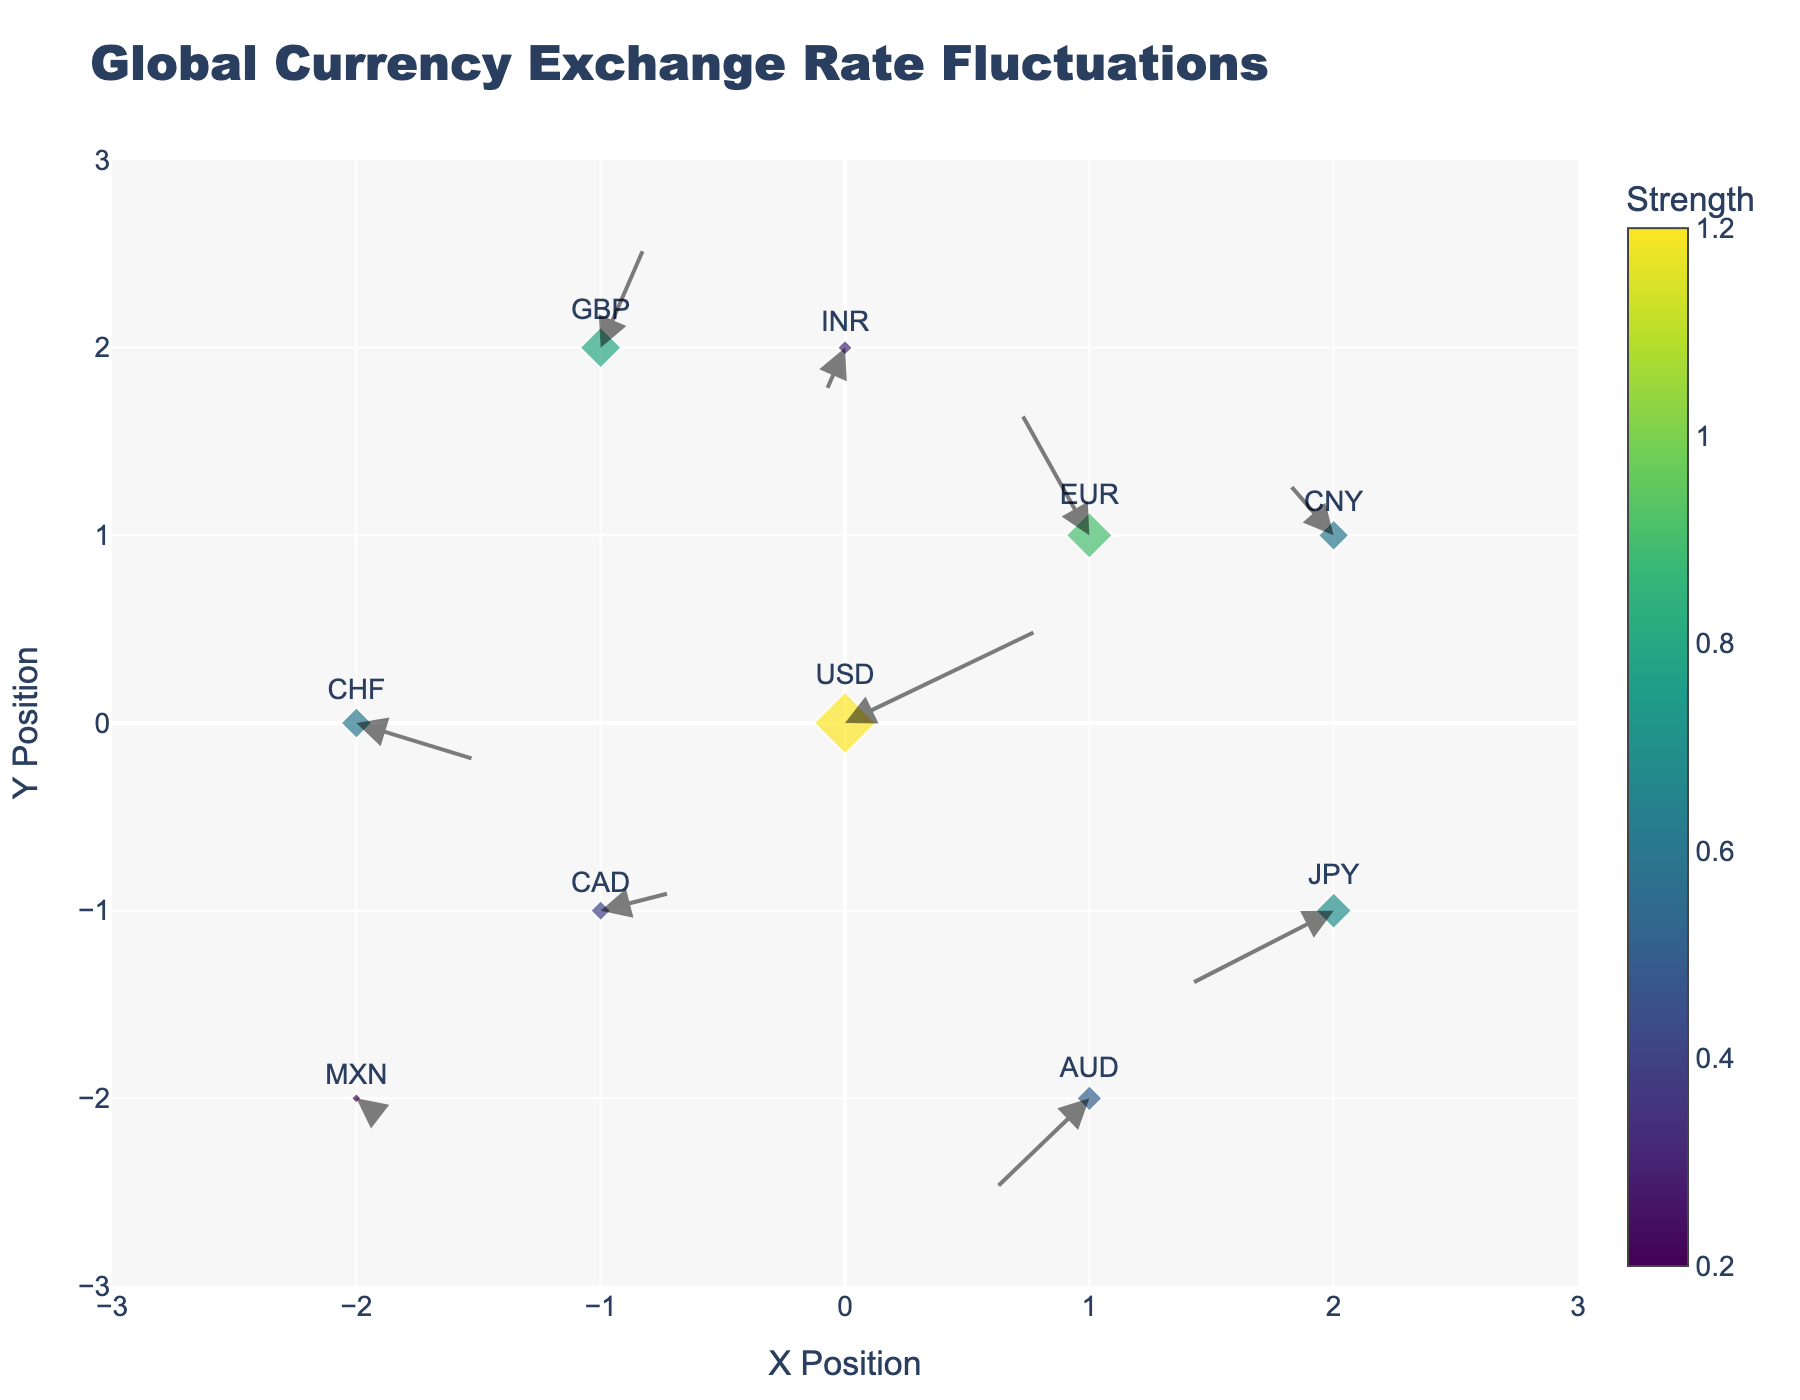What is the title of the figure? The title is located at the top-center of the plot and usually provides the main subject of the visualization. In this case, it reads "Global Currency Exchange Rate Fluctuations."
Answer: Global Currency Exchange Rate Fluctuations How many currencies are represented in the plot? By counting the labeled markers in the plot, one can identify each currency. There are 10 labeled markers indicating 10 different currencies.
Answer: 10 Which currency has the highest strength value? By observing the size of the markers and the color bar, the currency with the largest marker size and darkest color typically indicates the highest strength. In this case, USD has the highest strength of 1.2.
Answer: USD Which direction is the EUR moving? Check the vector or arrow starting from the EUR marker. The arrow points in a certain direction from the origin of the EUR marker. EUR is moving upwards and slightly to the left.
Answer: Upwards and to the left Which currency has the smallest strength, and what is its value? Looking at the smallest marker size and the corresponding color in the color bar, MXN has the smallest strength value of 0.2.
Answer: MXN, 0.2 What is the average strength of JPY and GBP? First, locate JPY and GBP, then note their strength values. JPY has a strength of 0.7 and GBP has a strength of 0.8. Average = (0.7 + 0.8) / 2 = 0.75.
Answer: 0.75 Which two currencies are closest in position? By observing the positions on the plot, the nearest markers to each other are EUR (1, 1) and CNY (2, 1). These two are closest in position.
Answer: EUR and CNY What's the combined X movement (U values) of AUD and CAD? The U components for AUD and CAD are -0.4 and 0.3 respectively. Sum them up: -0.4 + 0.3 = -0.1.
Answer: -0.1 Which currency is moving downward most steeply? Look for arrows pointing downward and observe the angle or steepness. JPY, with a downward vector component V of -0.4, shows the most considerable downward movement.
Answer: JPY Which currencies are moving towards the X-axis, and which are moving away from it? By evaluating the direction of the arrows for each currency, we can determine the motion relative to the X-axis. Currencies with downward or upward components (V) show movement towards or away from the X-axis: Towards X-axis - JPY, AUD, INR, MXN; Away from X-axis - USD, EUR, GBP, CHF, CAD, CNY.
Answer: Towards: JPY, AUD, INR, MXN; Away: USD, EUR, GBP, CHF, CAD, CNY 